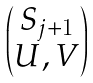<formula> <loc_0><loc_0><loc_500><loc_500>\begin{pmatrix} S _ { j + 1 } \\ U , V \end{pmatrix}</formula> 